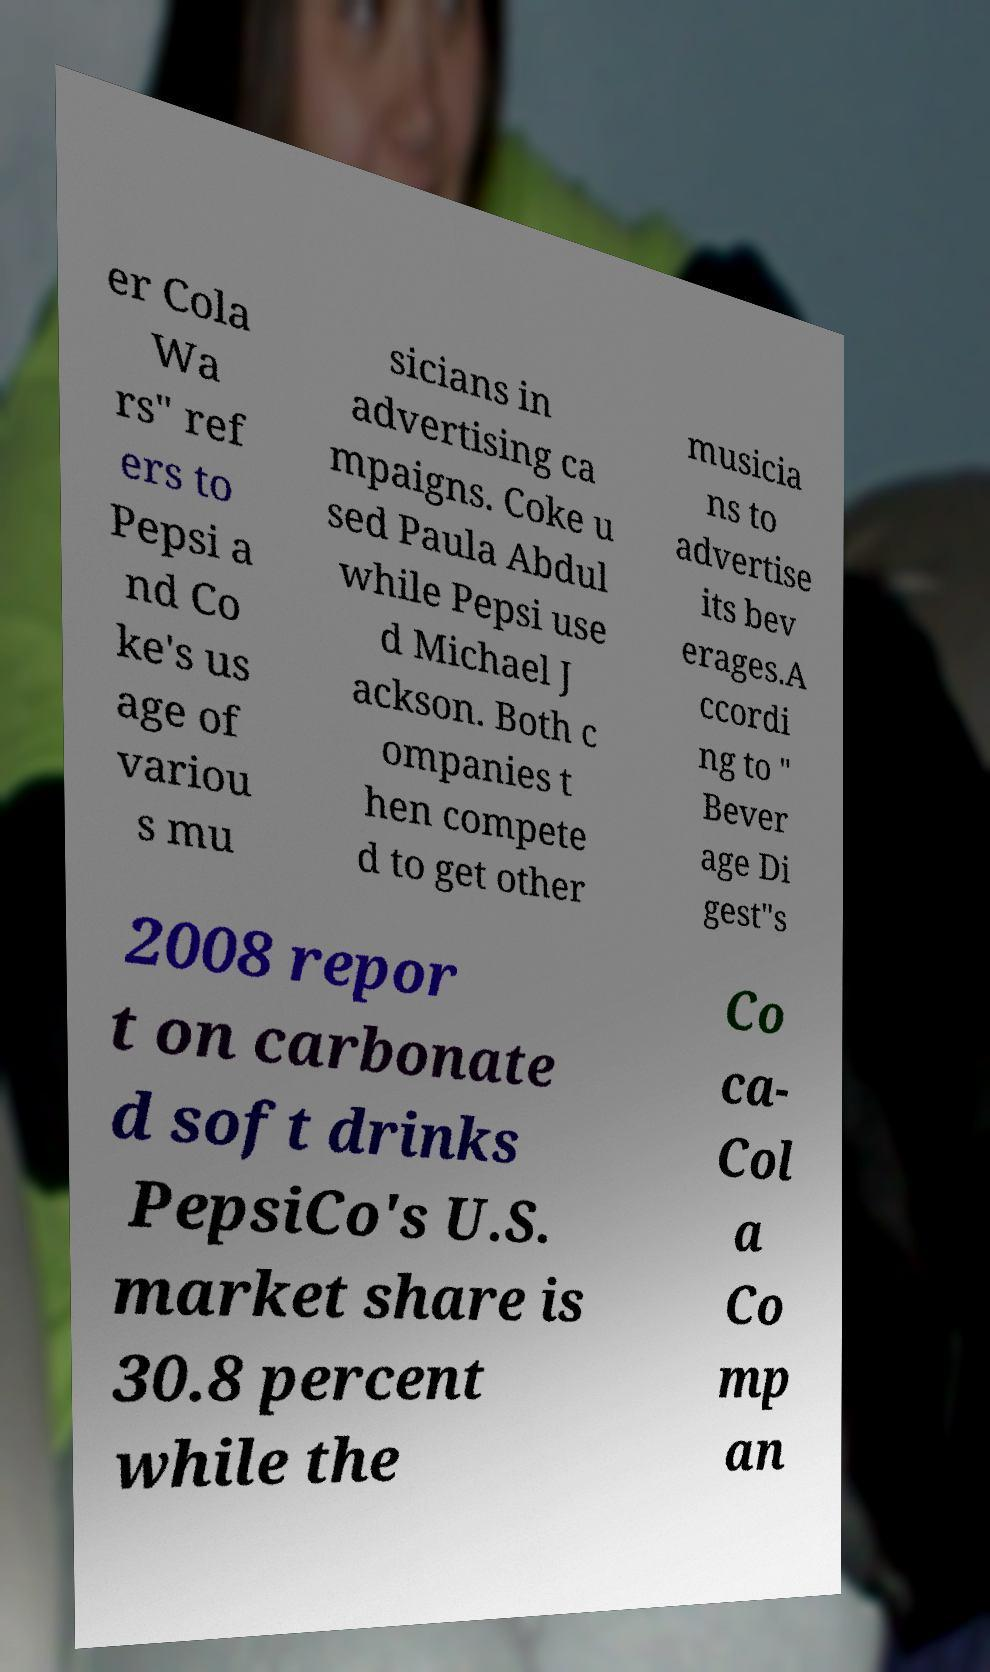Can you accurately transcribe the text from the provided image for me? er Cola Wa rs" ref ers to Pepsi a nd Co ke's us age of variou s mu sicians in advertising ca mpaigns. Coke u sed Paula Abdul while Pepsi use d Michael J ackson. Both c ompanies t hen compete d to get other musicia ns to advertise its bev erages.A ccordi ng to " Bever age Di gest"s 2008 repor t on carbonate d soft drinks PepsiCo's U.S. market share is 30.8 percent while the Co ca- Col a Co mp an 